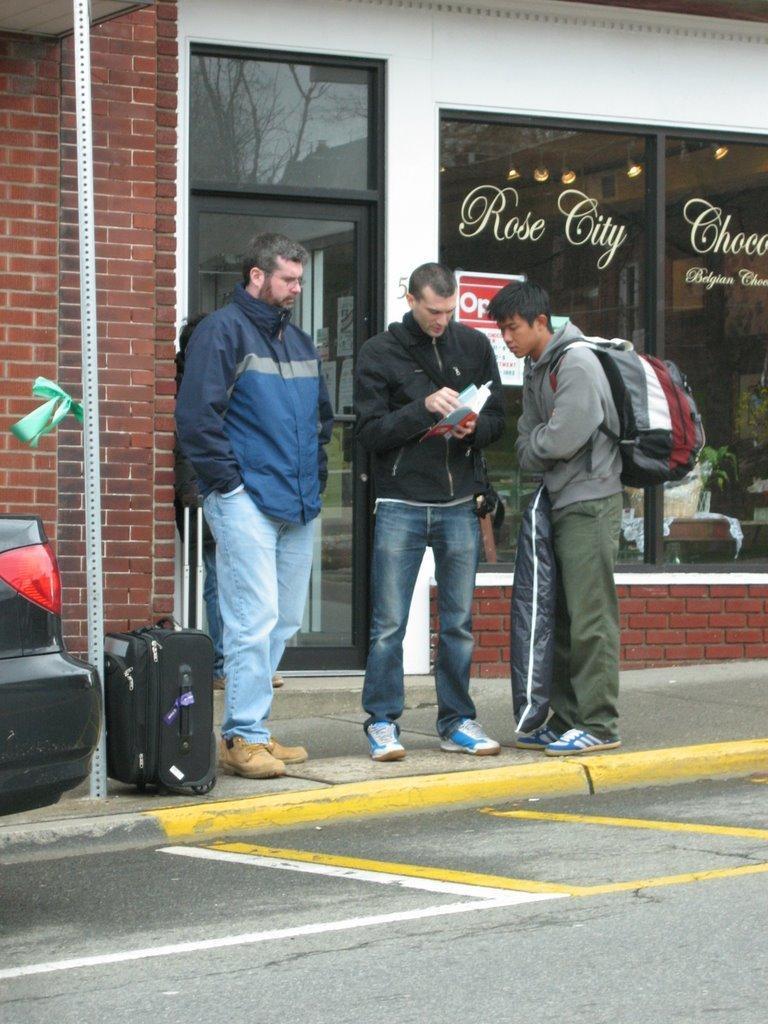Could you give a brief overview of what you see in this image? In this picture we can see three persons on right side man carrying bag, in middle searching something in the book and left side person is watching them and in the background we can see building with glass doors and windows and in front of them there is a road and here it is a car and this three persons are standing on foot path. 